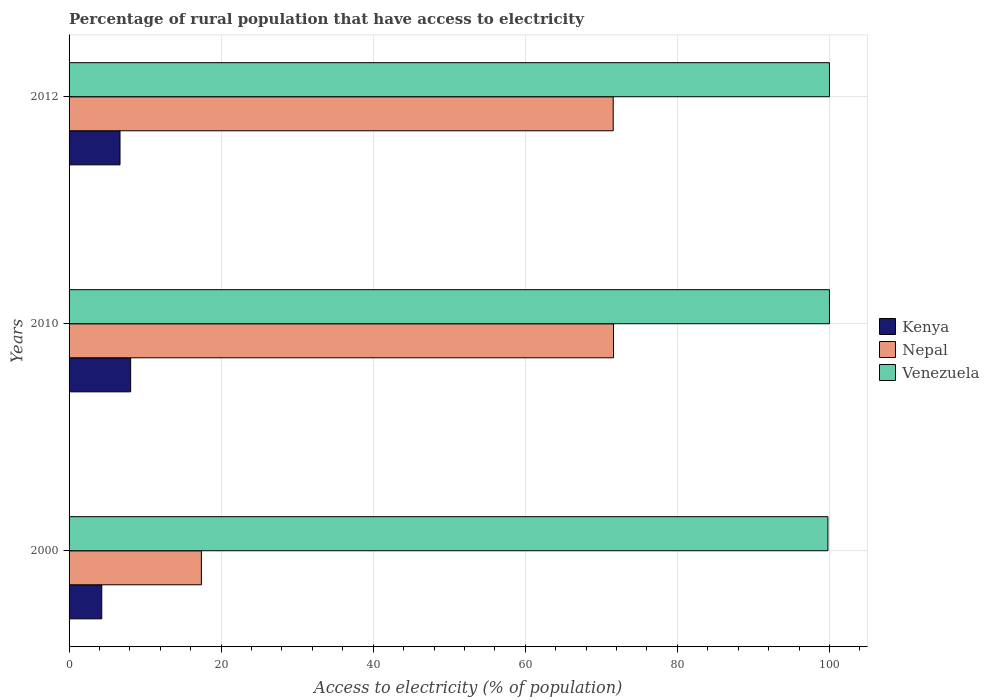How many different coloured bars are there?
Provide a succinct answer. 3. How many bars are there on the 3rd tick from the bottom?
Your response must be concise. 3. In how many cases, is the number of bars for a given year not equal to the number of legend labels?
Give a very brief answer. 0. What is the percentage of rural population that have access to electricity in Kenya in 2012?
Offer a terse response. 6.7. Across all years, what is the maximum percentage of rural population that have access to electricity in Nepal?
Your answer should be compact. 71.6. Across all years, what is the minimum percentage of rural population that have access to electricity in Venezuela?
Make the answer very short. 99.8. In which year was the percentage of rural population that have access to electricity in Nepal maximum?
Give a very brief answer. 2010. What is the total percentage of rural population that have access to electricity in Nepal in the graph?
Your response must be concise. 160.56. What is the difference between the percentage of rural population that have access to electricity in Nepal in 2010 and that in 2012?
Offer a terse response. 0.04. What is the difference between the percentage of rural population that have access to electricity in Kenya in 2000 and the percentage of rural population that have access to electricity in Nepal in 2012?
Your answer should be compact. -67.26. What is the average percentage of rural population that have access to electricity in Venezuela per year?
Ensure brevity in your answer.  99.93. In the year 2010, what is the difference between the percentage of rural population that have access to electricity in Nepal and percentage of rural population that have access to electricity in Venezuela?
Offer a terse response. -28.4. What is the ratio of the percentage of rural population that have access to electricity in Kenya in 2010 to that in 2012?
Offer a terse response. 1.21. Is the percentage of rural population that have access to electricity in Kenya in 2000 less than that in 2010?
Offer a very short reply. Yes. Is the difference between the percentage of rural population that have access to electricity in Nepal in 2010 and 2012 greater than the difference between the percentage of rural population that have access to electricity in Venezuela in 2010 and 2012?
Ensure brevity in your answer.  Yes. What is the difference between the highest and the second highest percentage of rural population that have access to electricity in Nepal?
Ensure brevity in your answer.  0.04. What is the difference between the highest and the lowest percentage of rural population that have access to electricity in Venezuela?
Your response must be concise. 0.2. In how many years, is the percentage of rural population that have access to electricity in Nepal greater than the average percentage of rural population that have access to electricity in Nepal taken over all years?
Provide a short and direct response. 2. What does the 3rd bar from the top in 2012 represents?
Make the answer very short. Kenya. What does the 1st bar from the bottom in 2012 represents?
Your answer should be very brief. Kenya. Are all the bars in the graph horizontal?
Provide a short and direct response. Yes. What is the difference between two consecutive major ticks on the X-axis?
Keep it short and to the point. 20. Does the graph contain grids?
Ensure brevity in your answer.  Yes. What is the title of the graph?
Offer a terse response. Percentage of rural population that have access to electricity. Does "Thailand" appear as one of the legend labels in the graph?
Your answer should be very brief. No. What is the label or title of the X-axis?
Your response must be concise. Access to electricity (% of population). What is the Access to electricity (% of population) in Kenya in 2000?
Give a very brief answer. 4.3. What is the Access to electricity (% of population) of Venezuela in 2000?
Your answer should be compact. 99.8. What is the Access to electricity (% of population) of Nepal in 2010?
Keep it short and to the point. 71.6. What is the Access to electricity (% of population) of Nepal in 2012?
Make the answer very short. 71.56. Across all years, what is the maximum Access to electricity (% of population) of Nepal?
Keep it short and to the point. 71.6. Across all years, what is the minimum Access to electricity (% of population) in Kenya?
Offer a very short reply. 4.3. Across all years, what is the minimum Access to electricity (% of population) of Venezuela?
Your answer should be very brief. 99.8. What is the total Access to electricity (% of population) of Nepal in the graph?
Give a very brief answer. 160.56. What is the total Access to electricity (% of population) of Venezuela in the graph?
Offer a very short reply. 299.8. What is the difference between the Access to electricity (% of population) of Nepal in 2000 and that in 2010?
Offer a very short reply. -54.2. What is the difference between the Access to electricity (% of population) of Kenya in 2000 and that in 2012?
Give a very brief answer. -2.4. What is the difference between the Access to electricity (% of population) in Nepal in 2000 and that in 2012?
Give a very brief answer. -54.16. What is the difference between the Access to electricity (% of population) in Venezuela in 2000 and that in 2012?
Your answer should be compact. -0.2. What is the difference between the Access to electricity (% of population) in Kenya in 2000 and the Access to electricity (% of population) in Nepal in 2010?
Your answer should be very brief. -67.3. What is the difference between the Access to electricity (% of population) of Kenya in 2000 and the Access to electricity (% of population) of Venezuela in 2010?
Offer a very short reply. -95.7. What is the difference between the Access to electricity (% of population) in Nepal in 2000 and the Access to electricity (% of population) in Venezuela in 2010?
Your response must be concise. -82.6. What is the difference between the Access to electricity (% of population) of Kenya in 2000 and the Access to electricity (% of population) of Nepal in 2012?
Offer a very short reply. -67.26. What is the difference between the Access to electricity (% of population) of Kenya in 2000 and the Access to electricity (% of population) of Venezuela in 2012?
Your answer should be very brief. -95.7. What is the difference between the Access to electricity (% of population) in Nepal in 2000 and the Access to electricity (% of population) in Venezuela in 2012?
Your answer should be compact. -82.6. What is the difference between the Access to electricity (% of population) of Kenya in 2010 and the Access to electricity (% of population) of Nepal in 2012?
Your answer should be very brief. -63.46. What is the difference between the Access to electricity (% of population) in Kenya in 2010 and the Access to electricity (% of population) in Venezuela in 2012?
Your answer should be compact. -91.9. What is the difference between the Access to electricity (% of population) in Nepal in 2010 and the Access to electricity (% of population) in Venezuela in 2012?
Provide a short and direct response. -28.4. What is the average Access to electricity (% of population) in Kenya per year?
Provide a succinct answer. 6.37. What is the average Access to electricity (% of population) in Nepal per year?
Offer a very short reply. 53.52. What is the average Access to electricity (% of population) in Venezuela per year?
Give a very brief answer. 99.93. In the year 2000, what is the difference between the Access to electricity (% of population) in Kenya and Access to electricity (% of population) in Venezuela?
Offer a very short reply. -95.5. In the year 2000, what is the difference between the Access to electricity (% of population) of Nepal and Access to electricity (% of population) of Venezuela?
Offer a terse response. -82.4. In the year 2010, what is the difference between the Access to electricity (% of population) in Kenya and Access to electricity (% of population) in Nepal?
Ensure brevity in your answer.  -63.5. In the year 2010, what is the difference between the Access to electricity (% of population) of Kenya and Access to electricity (% of population) of Venezuela?
Keep it short and to the point. -91.9. In the year 2010, what is the difference between the Access to electricity (% of population) of Nepal and Access to electricity (% of population) of Venezuela?
Offer a very short reply. -28.4. In the year 2012, what is the difference between the Access to electricity (% of population) in Kenya and Access to electricity (% of population) in Nepal?
Offer a terse response. -64.86. In the year 2012, what is the difference between the Access to electricity (% of population) of Kenya and Access to electricity (% of population) of Venezuela?
Your response must be concise. -93.3. In the year 2012, what is the difference between the Access to electricity (% of population) of Nepal and Access to electricity (% of population) of Venezuela?
Offer a very short reply. -28.44. What is the ratio of the Access to electricity (% of population) of Kenya in 2000 to that in 2010?
Keep it short and to the point. 0.53. What is the ratio of the Access to electricity (% of population) in Nepal in 2000 to that in 2010?
Your answer should be very brief. 0.24. What is the ratio of the Access to electricity (% of population) in Kenya in 2000 to that in 2012?
Keep it short and to the point. 0.64. What is the ratio of the Access to electricity (% of population) in Nepal in 2000 to that in 2012?
Your response must be concise. 0.24. What is the ratio of the Access to electricity (% of population) in Venezuela in 2000 to that in 2012?
Make the answer very short. 1. What is the ratio of the Access to electricity (% of population) of Kenya in 2010 to that in 2012?
Offer a terse response. 1.21. What is the ratio of the Access to electricity (% of population) in Venezuela in 2010 to that in 2012?
Offer a very short reply. 1. What is the difference between the highest and the second highest Access to electricity (% of population) in Nepal?
Offer a terse response. 0.04. What is the difference between the highest and the lowest Access to electricity (% of population) of Nepal?
Offer a terse response. 54.2. 